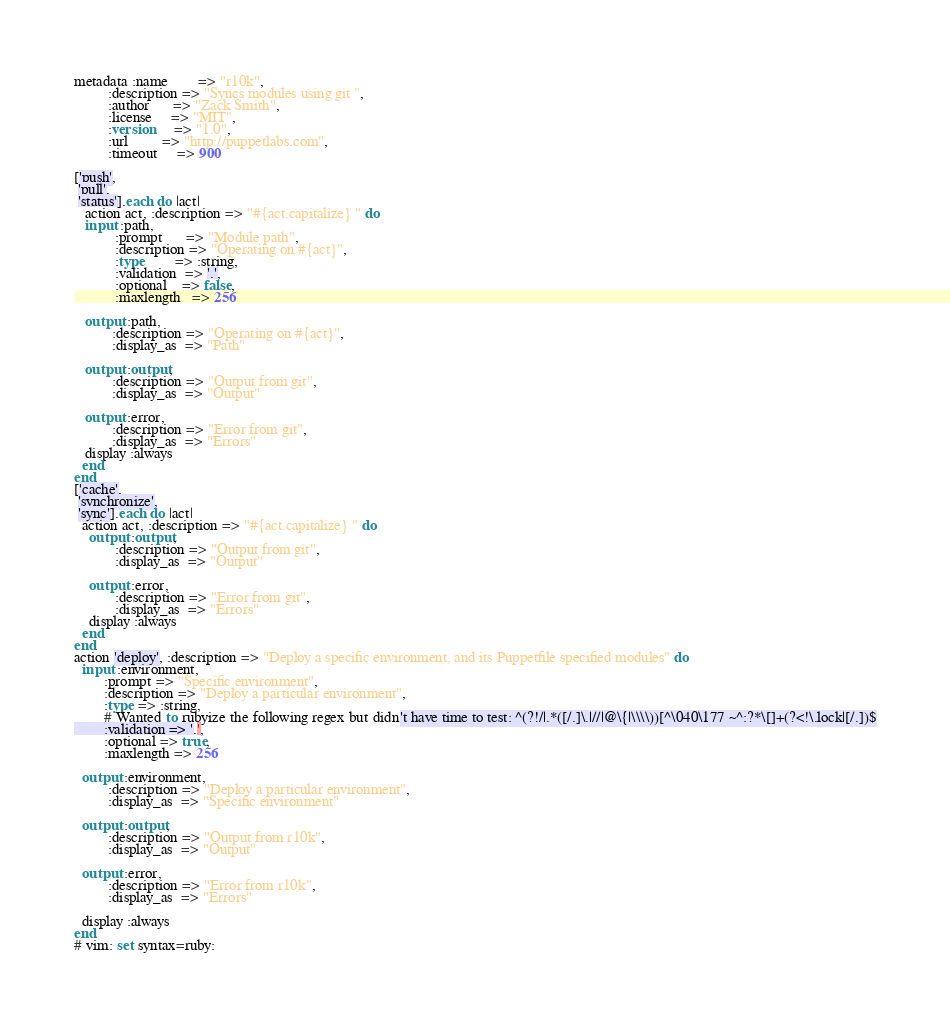<code> <loc_0><loc_0><loc_500><loc_500><_SQL_>metadata :name        => "r10k",
         :description => "Syncs modules using git ",
         :author      => "Zack Smith",
         :license     => "MIT",
         :version     => "1.0",
         :url         => "http://puppetlabs.com",
         :timeout     => 900

['push',
 'pull',
 'status'].each do |act|
   action act, :description => "#{act.capitalize} " do
   input :path,
           :prompt      => "Module path",
           :description => "Operating on #{act}",
           :type        => :string,
           :validation  => '.',
           :optional    => false,
           :maxlength   => 256

   output :path,
          :description => "Operating on #{act}",
          :display_as  => "Path"

   output :output,
          :description => "Output from git",
          :display_as  => "Output"

   output :error,
          :description => "Error from git",
          :display_as  => "Errors"
   display :always
  end
end
['cache',
 'synchronize',
 'sync'].each do |act|
  action act, :description => "#{act.capitalize} " do
    output :output,
           :description => "Output from git",
           :display_as  => "Output"

    output :error,
           :description => "Error from git",
           :display_as  => "Errors"
    display :always
  end
end
action 'deploy', :description => "Deploy a specific environment, and its Puppetfile specified modules" do
  input :environment,
        :prompt => "Specific environment",
        :description => "Deploy a particular environment",
        :type => :string,
        # Wanted to rubyize the following regex but didn't have time to test: ^(?!/|.*([/.]\.|//|@\{|\\\\))[^\040\177 ~^:?*\[]+(?<!\.lock|[/.])$
        :validation => '.',
        :optional => true,
        :maxlength => 256 
  
  output :environment,
         :description => "Deploy a particular environment",
         :display_as  => "Specific environment"
  
  output :output,
         :description => "Output from r10k",
         :display_as  => "Output"
  
  output :error,
         :description => "Error from r10k",
         :display_as  => "Errors"
  
  display :always
end
# vim: set syntax=ruby:
</code> 